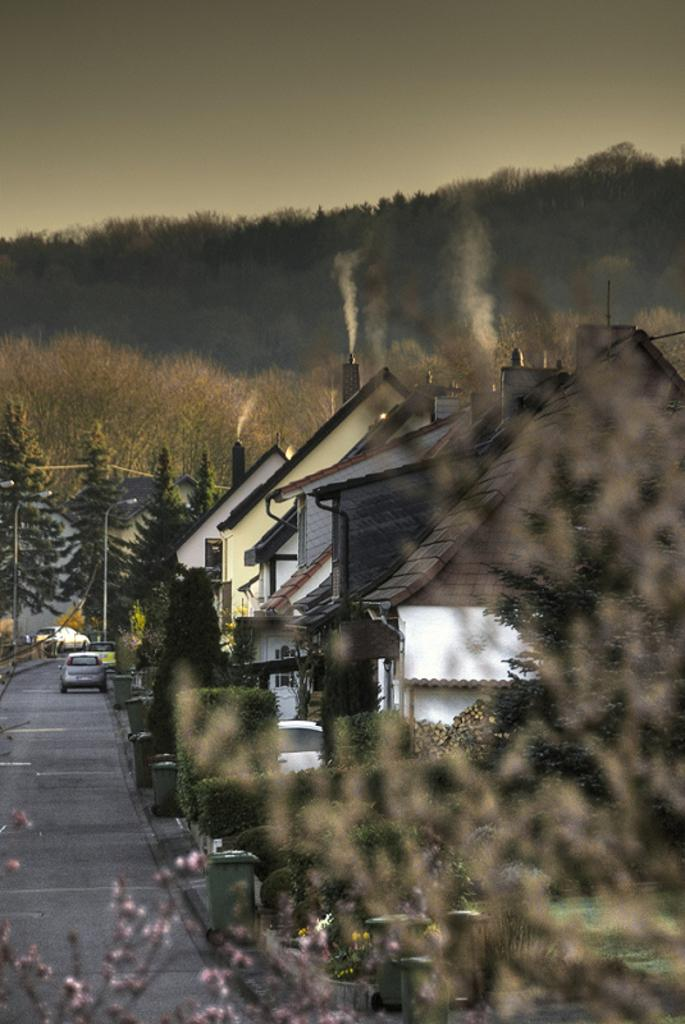What is located in the center of the image? There are houses and trees in the center of the image. What can be seen on the left side of the image? There are cars on the left side of the image. What type of vegetation is present in the background area of the image? There are trees in the background area of the image. What time of day is depicted in the image, and how does the foot contribute to this scene? The time of day cannot be determined from the image, and there is no foot present in the image. 